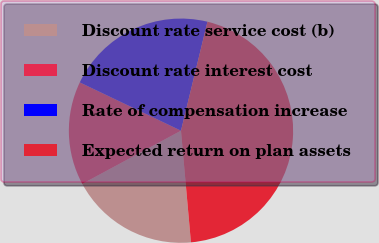Convert chart. <chart><loc_0><loc_0><loc_500><loc_500><pie_chart><fcel>Discount rate service cost (b)<fcel>Discount rate interest cost<fcel>Rate of compensation increase<fcel>Expected return on plan assets<nl><fcel>18.55%<fcel>14.95%<fcel>21.71%<fcel>44.79%<nl></chart> 